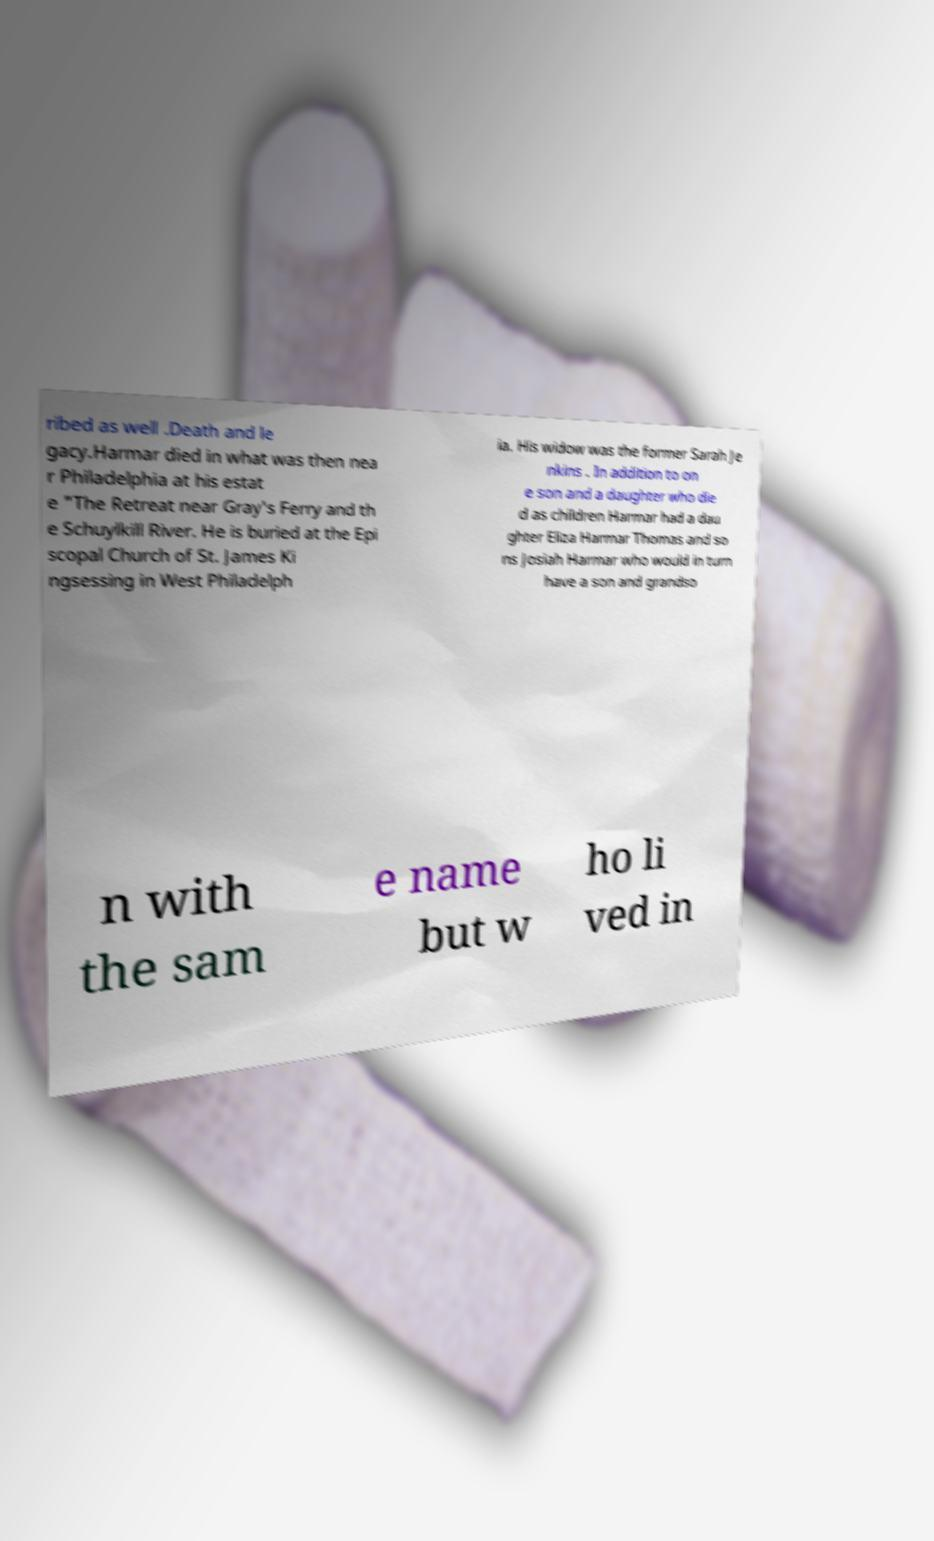There's text embedded in this image that I need extracted. Can you transcribe it verbatim? ribed as well .Death and le gacy.Harmar died in what was then nea r Philadelphia at his estat e "The Retreat near Gray's Ferry and th e Schuylkill River. He is buried at the Epi scopal Church of St. James Ki ngsessing in West Philadelph ia. His widow was the former Sarah Je nkins . In addition to on e son and a daughter who die d as children Harmar had a dau ghter Eliza Harmar Thomas and so ns Josiah Harmar who would in turn have a son and grandso n with the sam e name but w ho li ved in 